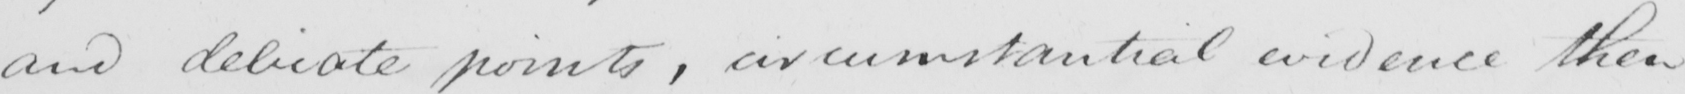Can you tell me what this handwritten text says? and delicate points , circumstantial evidence then 